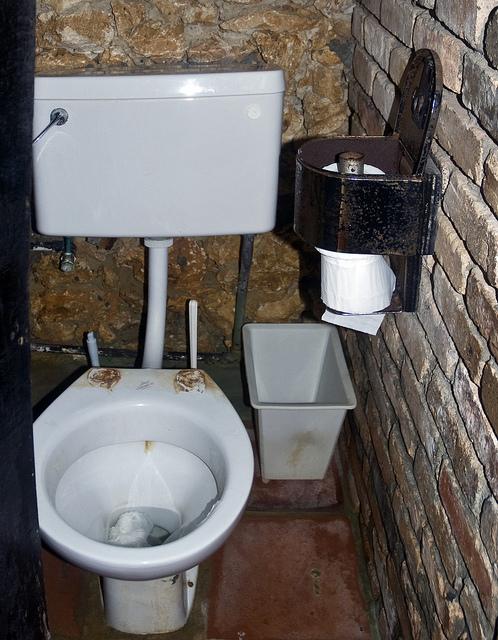What is wrong with this bathroom wall?
Give a very brief answer. Dirty. Does this toilet look clean?
Be succinct. No. Is there a garbage can in the room?
Quick response, please. Yes. What is the wall on the right made out of?
Be succinct. Brick. Is this toilet for a male or female?
Keep it brief. Male. 